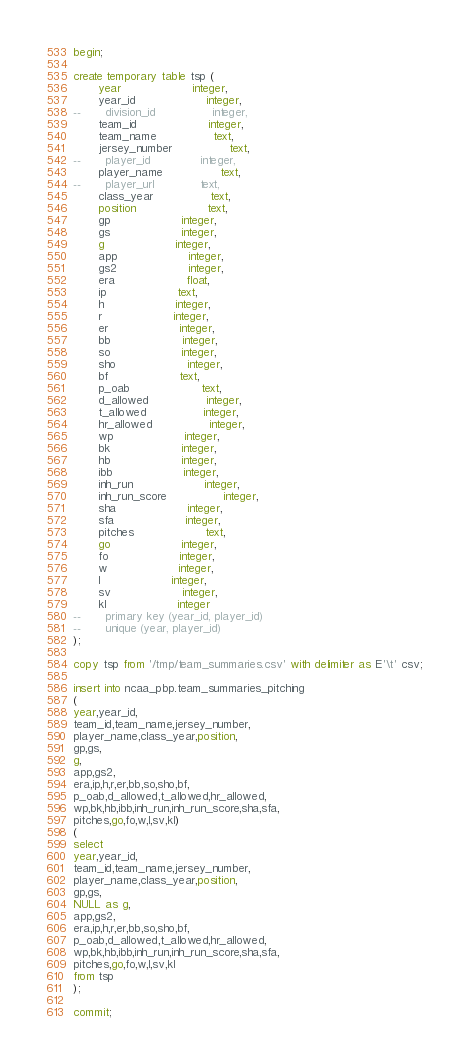<code> <loc_0><loc_0><loc_500><loc_500><_SQL_>begin;

create temporary table tsp (
       year					integer,
       year_id					integer,
--       division_id				integer,
       team_id					integer,
       team_name				text,
       jersey_number				text,
--       player_id				integer,
       player_name				text,
--       player_url				text,
       class_year				text,
       position					text,
       gp					integer,
       gs					integer,
       g					integer,
       app					integer,
       gs2					integer,
       era					float,
       ip					text,
       h					integer,
       r					integer,
       er					integer,
       bb					integer,
       so					integer,
       sho					integer,
       bf					text,
       p_oab					text,
       d_allowed				integer,
       t_allowed				integer,
       hr_allowed				integer,
       wp					integer,
       bk					integer,
       hb					integer,
       ibb					integer,
       inh_run					integer,
       inh_run_score				integer,
       sha					integer,
       sfa					integer,
       pitches					text,
       go					integer,
       fo					integer,
       w					integer,
       l					integer,
       sv					integer,
       kl					integer
--       primary key (year_id, player_id)
--       unique (year, player_id)
);

copy tsp from '/tmp/team_summaries.csv' with delimiter as E'\t' csv;

insert into ncaa_pbp.team_summaries_pitching
(
year,year_id,
team_id,team_name,jersey_number,
player_name,class_year,position,
gp,gs,
g,
app,gs2,
era,ip,h,r,er,bb,so,sho,bf,
p_oab,d_allowed,t_allowed,hr_allowed,
wp,bk,hb,ibb,inh_run,inh_run_score,sha,sfa,
pitches,go,fo,w,l,sv,kl)
(
select
year,year_id,
team_id,team_name,jersey_number,
player_name,class_year,position,
gp,gs,
NULL as g,
app,gs2,
era,ip,h,r,er,bb,so,sho,bf,
p_oab,d_allowed,t_allowed,hr_allowed,
wp,bk,hb,ibb,inh_run,inh_run_score,sha,sfa,
pitches,go,fo,w,l,sv,kl
from tsp
);

commit;
</code> 